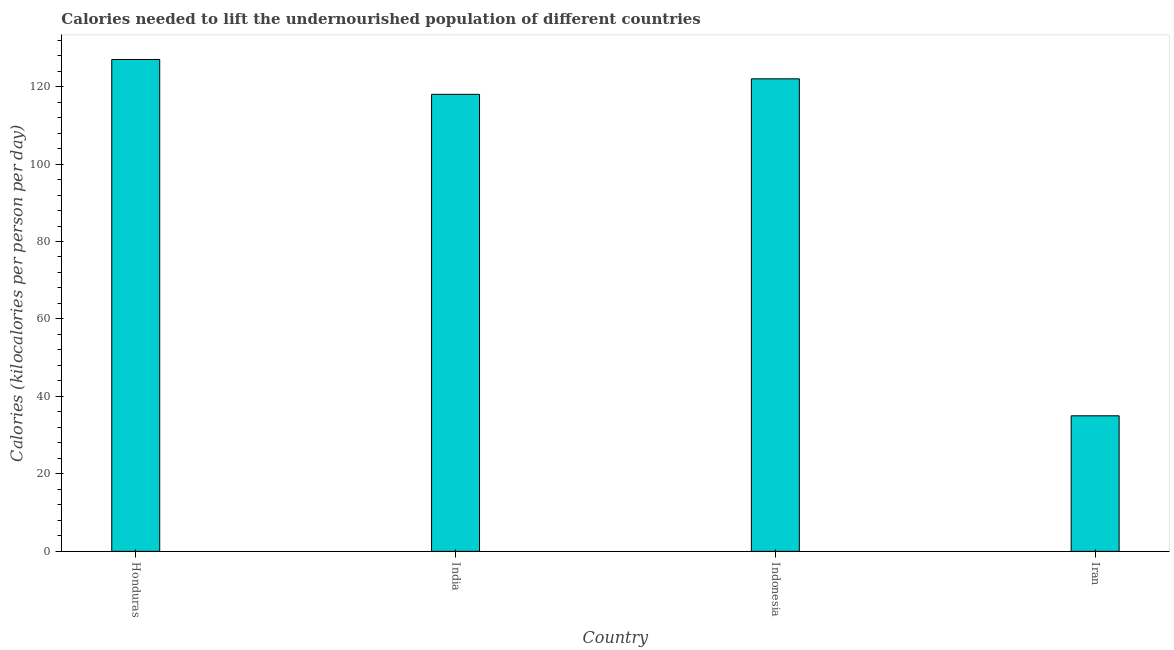What is the title of the graph?
Give a very brief answer. Calories needed to lift the undernourished population of different countries. What is the label or title of the Y-axis?
Keep it short and to the point. Calories (kilocalories per person per day). What is the depth of food deficit in Honduras?
Make the answer very short. 127. Across all countries, what is the maximum depth of food deficit?
Give a very brief answer. 127. Across all countries, what is the minimum depth of food deficit?
Your answer should be very brief. 35. In which country was the depth of food deficit maximum?
Your answer should be very brief. Honduras. In which country was the depth of food deficit minimum?
Keep it short and to the point. Iran. What is the sum of the depth of food deficit?
Give a very brief answer. 402. What is the difference between the depth of food deficit in Honduras and Iran?
Your response must be concise. 92. What is the average depth of food deficit per country?
Your response must be concise. 100.5. What is the median depth of food deficit?
Offer a terse response. 120. In how many countries, is the depth of food deficit greater than 100 kilocalories?
Ensure brevity in your answer.  3. What is the ratio of the depth of food deficit in Indonesia to that in Iran?
Your response must be concise. 3.49. Is the difference between the depth of food deficit in Honduras and Iran greater than the difference between any two countries?
Give a very brief answer. Yes. Is the sum of the depth of food deficit in India and Indonesia greater than the maximum depth of food deficit across all countries?
Your answer should be very brief. Yes. What is the difference between the highest and the lowest depth of food deficit?
Your answer should be very brief. 92. In how many countries, is the depth of food deficit greater than the average depth of food deficit taken over all countries?
Offer a terse response. 3. Are all the bars in the graph horizontal?
Make the answer very short. No. How many countries are there in the graph?
Your response must be concise. 4. What is the difference between two consecutive major ticks on the Y-axis?
Ensure brevity in your answer.  20. Are the values on the major ticks of Y-axis written in scientific E-notation?
Your response must be concise. No. What is the Calories (kilocalories per person per day) in Honduras?
Give a very brief answer. 127. What is the Calories (kilocalories per person per day) in India?
Provide a succinct answer. 118. What is the Calories (kilocalories per person per day) in Indonesia?
Keep it short and to the point. 122. What is the difference between the Calories (kilocalories per person per day) in Honduras and Indonesia?
Give a very brief answer. 5. What is the difference between the Calories (kilocalories per person per day) in Honduras and Iran?
Keep it short and to the point. 92. What is the ratio of the Calories (kilocalories per person per day) in Honduras to that in India?
Provide a succinct answer. 1.08. What is the ratio of the Calories (kilocalories per person per day) in Honduras to that in Indonesia?
Ensure brevity in your answer.  1.04. What is the ratio of the Calories (kilocalories per person per day) in Honduras to that in Iran?
Give a very brief answer. 3.63. What is the ratio of the Calories (kilocalories per person per day) in India to that in Indonesia?
Your response must be concise. 0.97. What is the ratio of the Calories (kilocalories per person per day) in India to that in Iran?
Give a very brief answer. 3.37. What is the ratio of the Calories (kilocalories per person per day) in Indonesia to that in Iran?
Make the answer very short. 3.49. 